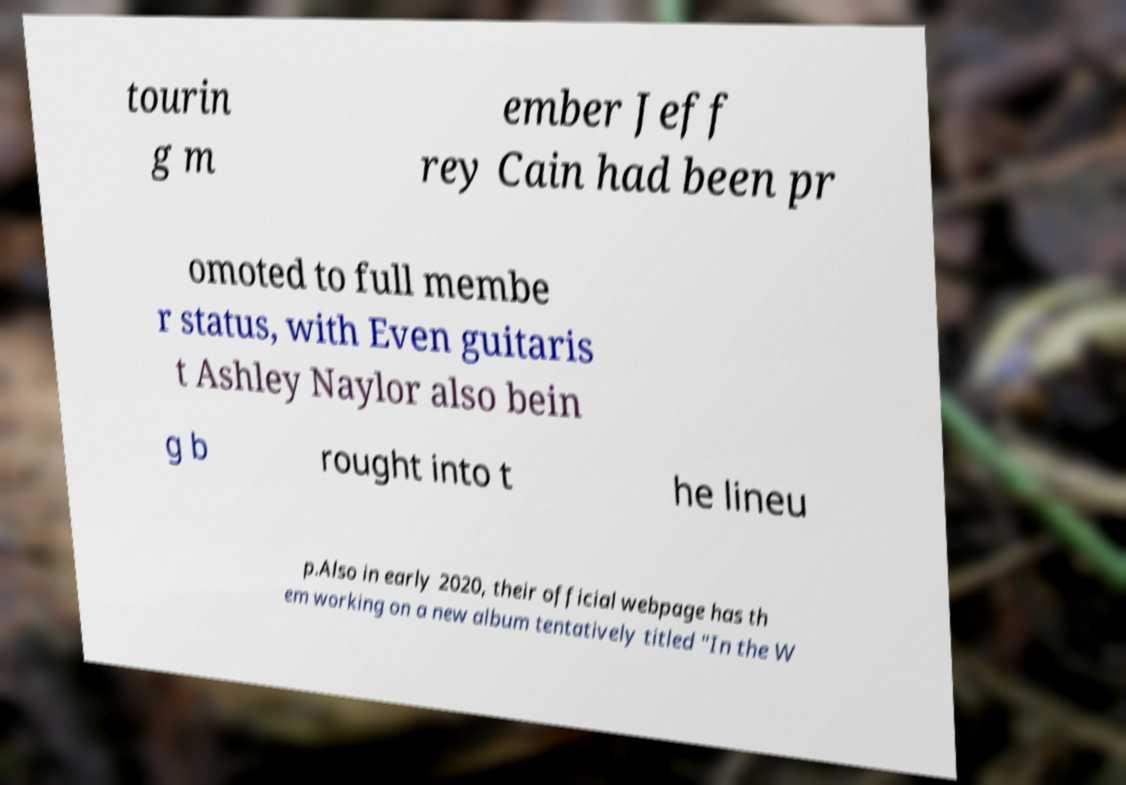Could you extract and type out the text from this image? tourin g m ember Jeff rey Cain had been pr omoted to full membe r status, with Even guitaris t Ashley Naylor also bein g b rought into t he lineu p.Also in early 2020, their official webpage has th em working on a new album tentatively titled "In the W 